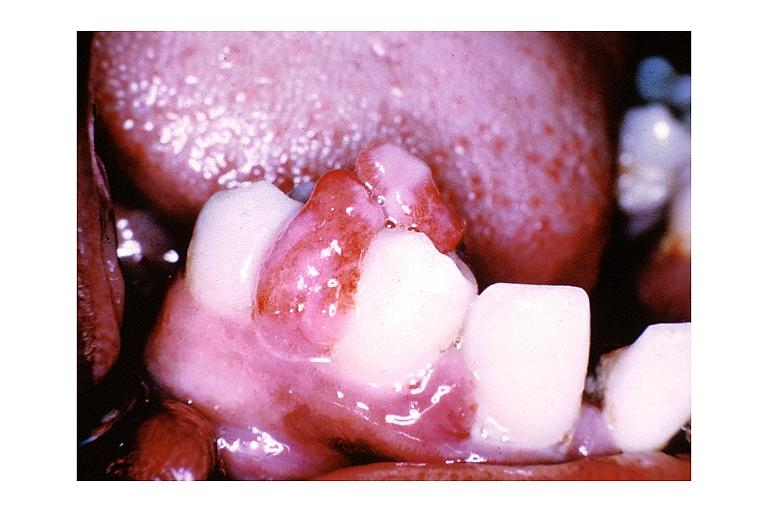does the tumor show pyogenic granuloma?
Answer the question using a single word or phrase. No 